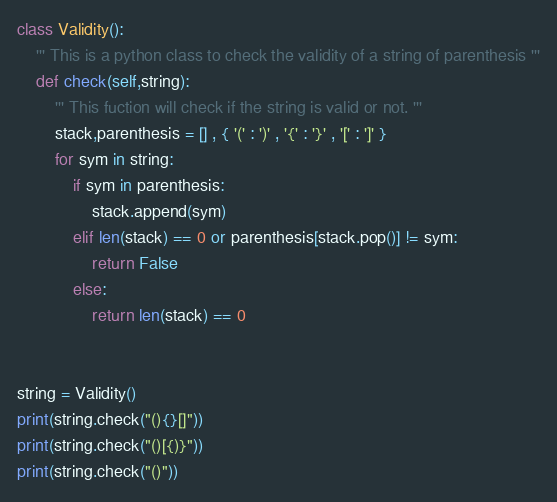Convert code to text. <code><loc_0><loc_0><loc_500><loc_500><_Python_>class Validity():
    ''' This is a python class to check the validity of a string of parenthesis '''
    def check(self,string):
        ''' This fuction will check if the string is valid or not. '''
        stack,parenthesis = [] , { '(' : ')' , '{' : '}' , '[' : ']' }
        for sym in string:
            if sym in parenthesis:
                stack.append(sym)
            elif len(stack) == 0 or parenthesis[stack.pop()] != sym:
                return False
            else:
                return len(stack) == 0


string = Validity()
print(string.check("(){}[]"))
print(string.check("()[{)}"))
print(string.check("()"))
</code> 